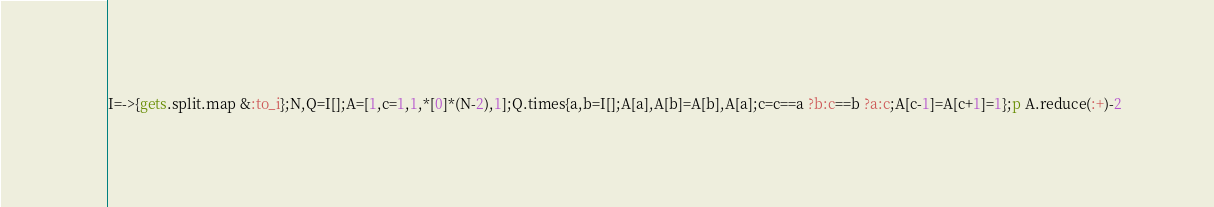Convert code to text. <code><loc_0><loc_0><loc_500><loc_500><_Ruby_>I=->{gets.split.map &:to_i};N,Q=I[];A=[1,c=1,1,*[0]*(N-2),1];Q.times{a,b=I[];A[a],A[b]=A[b],A[a];c=c==a ?b:c==b ?a:c;A[c-1]=A[c+1]=1};p A.reduce(:+)-2</code> 